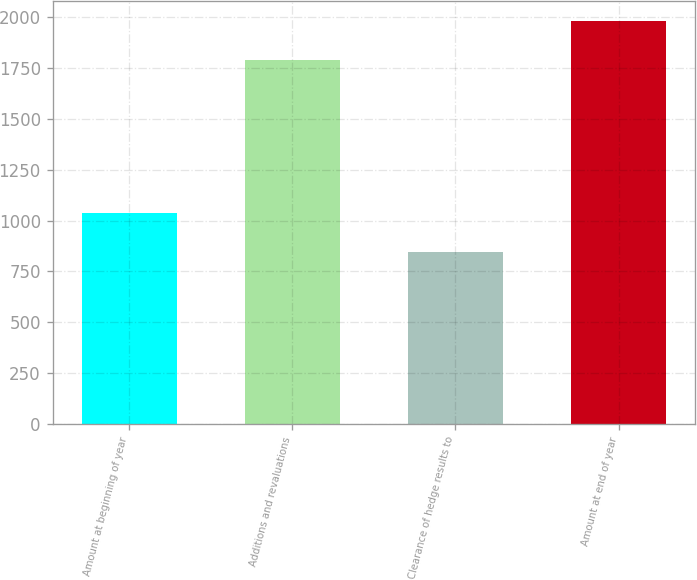Convert chart to OTSL. <chart><loc_0><loc_0><loc_500><loc_500><bar_chart><fcel>Amount at beginning of year<fcel>Additions and revaluations<fcel>Clearance of hedge results to<fcel>Amount at end of year<nl><fcel>1039<fcel>1789<fcel>845<fcel>1983<nl></chart> 